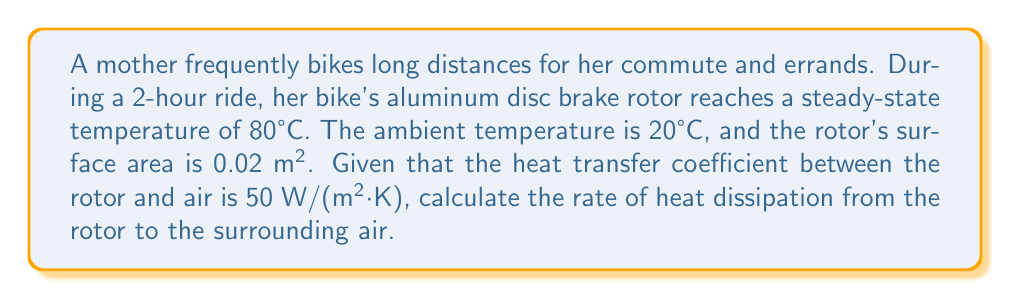Can you solve this math problem? To solve this problem, we'll use Newton's Law of Cooling:

$$Q = hA(T_s - T_∞)$$

Where:
$Q$ = Rate of heat transfer (W)
$h$ = Heat transfer coefficient (W/(m²·K))
$A$ = Surface area (m²)
$T_s$ = Surface temperature (°C)
$T_∞$ = Ambient temperature (°C)

Step 1: Identify the given values
$h = 50$ W/(m²·K)
$A = 0.02$ m²
$T_s = 80°C$
$T_∞ = 20°C$

Step 2: Substitute the values into the equation
$$Q = 50 \cdot 0.02 \cdot (80 - 20)$$

Step 3: Calculate the temperature difference
$$(80 - 20) = 60°C$$

Step 4: Multiply all values
$$Q = 50 \cdot 0.02 \cdot 60 = 60\text{ W}$$

Therefore, the rate of heat dissipation from the rotor to the surrounding air is 60 W.
Answer: 60 W 